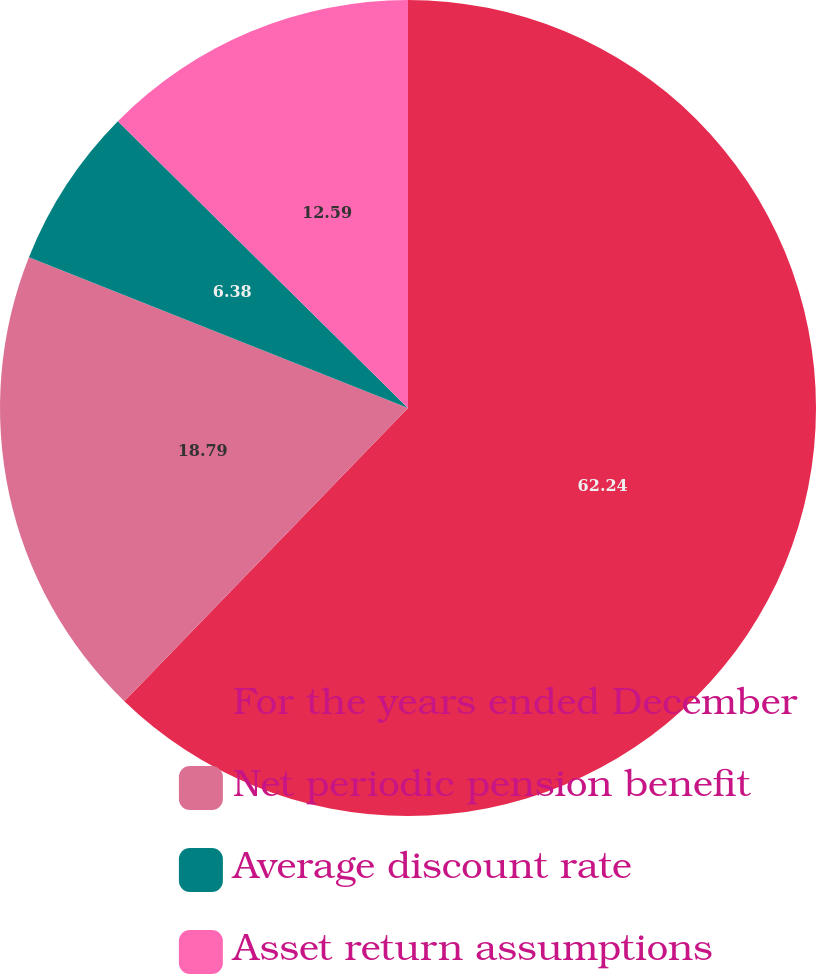Convert chart to OTSL. <chart><loc_0><loc_0><loc_500><loc_500><pie_chart><fcel>For the years ended December<fcel>Net periodic pension benefit<fcel>Average discount rate<fcel>Asset return assumptions<nl><fcel>62.23%<fcel>18.79%<fcel>6.38%<fcel>12.59%<nl></chart> 